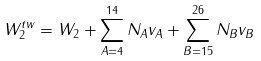<formula> <loc_0><loc_0><loc_500><loc_500>W _ { 2 } ^ { t w } = W _ { 2 } + \sum _ { A = 4 } ^ { 1 4 } N _ { A } v _ { A } + \sum _ { B = 1 5 } ^ { 2 6 } N _ { B } v _ { B }</formula> 